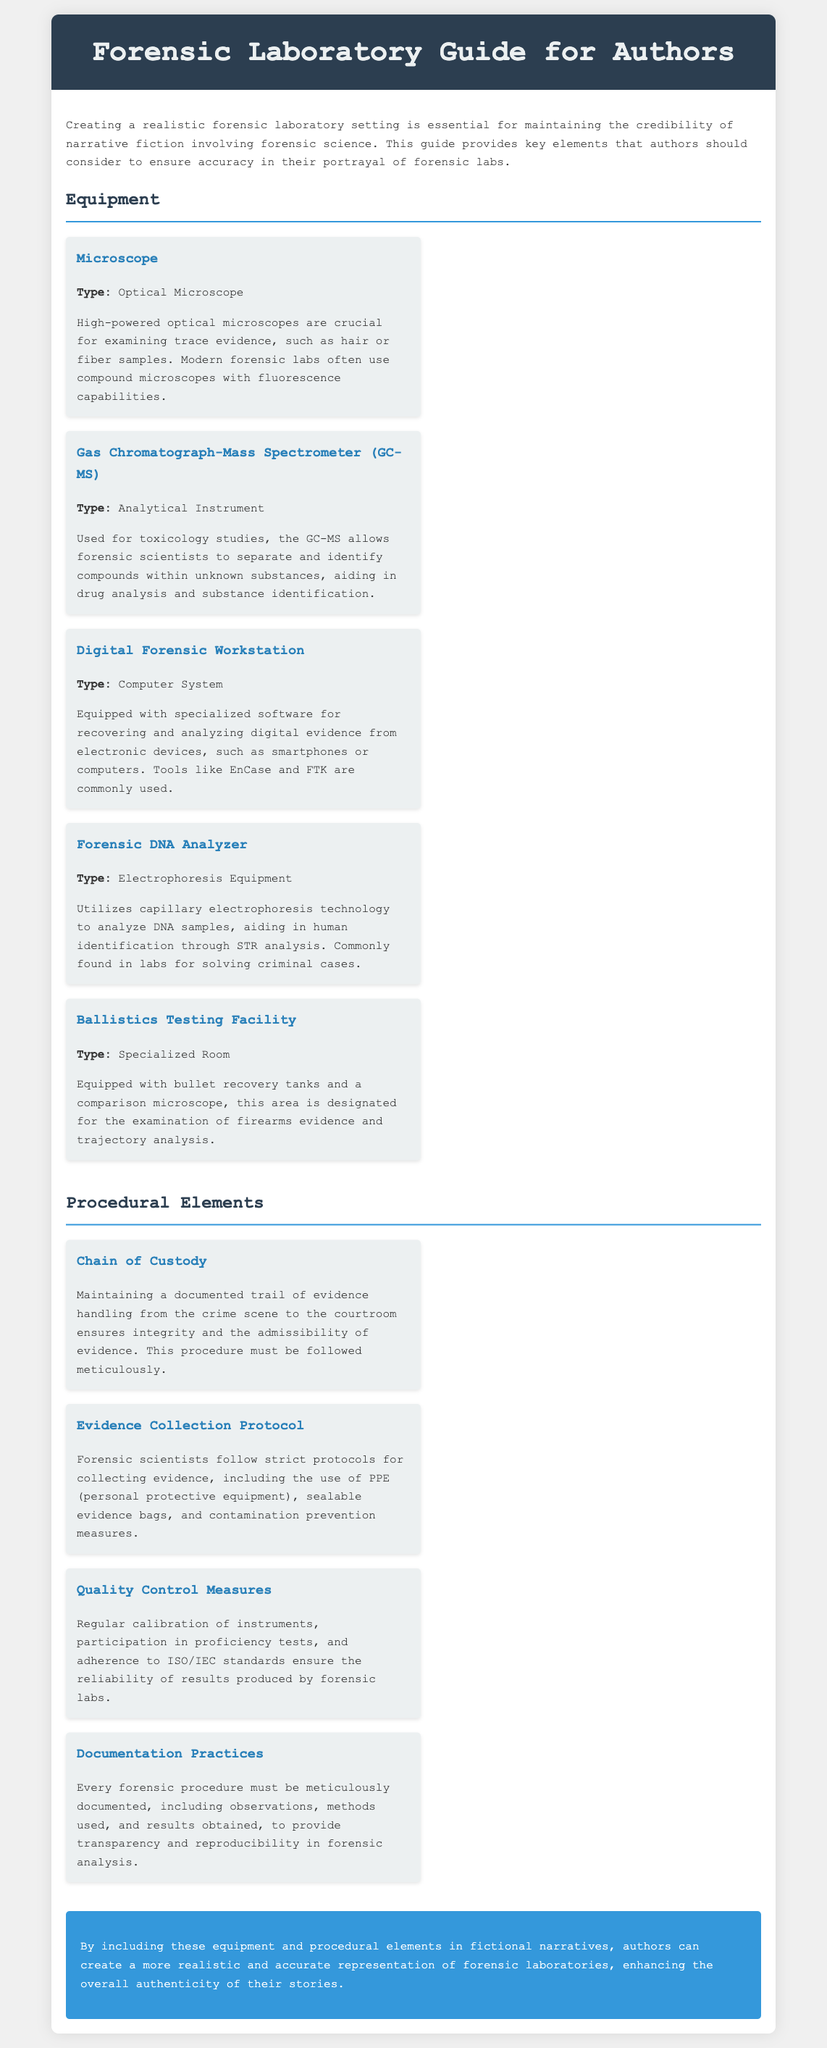What type of microscope is used in forensic labs? The document specifies that high-powered optical microscopes are crucial for examining trace evidence.
Answer: Optical Microscope What is the purpose of a Gas Chromatograph-Mass Spectrometer (GC-MS)? The document states that GC-MS is used for toxicology studies to separate and identify compounds.
Answer: Toxicology studies What does a Digital Forensic Workstation recover? According to the document, it recovers and analyzes digital evidence from electronic devices.
Answer: Digital evidence Which technology is utilized by the Forensic DNA Analyzer? The document mentions that it utilizes capillary electrophoresis technology for analyzing DNA samples.
Answer: Capillary electrophoresis What procedural element ensures the integrity of evidence? The document notes that maintaining a documented trail from crime scene to courtroom ensures integrity.
Answer: Chain of Custody What do quality control measures in forensic labs ensure? The document states that they ensure the reliability of results produced by forensic labs.
Answer: Reliability What type of equipment is a Ballistics Testing Facility categorized as? The document categorizes it as a specialized room for examining firearms evidence.
Answer: Specialized Room Why is documentation important in forensic procedures? The document explains that documentation provides transparency and reproducibility in forensic analysis.
Answer: Transparency and reproducibility What must forensic scientists follow for collecting evidence? The document outlines that they must follow strict protocols for collecting evidence.
Answer: Strict protocols 